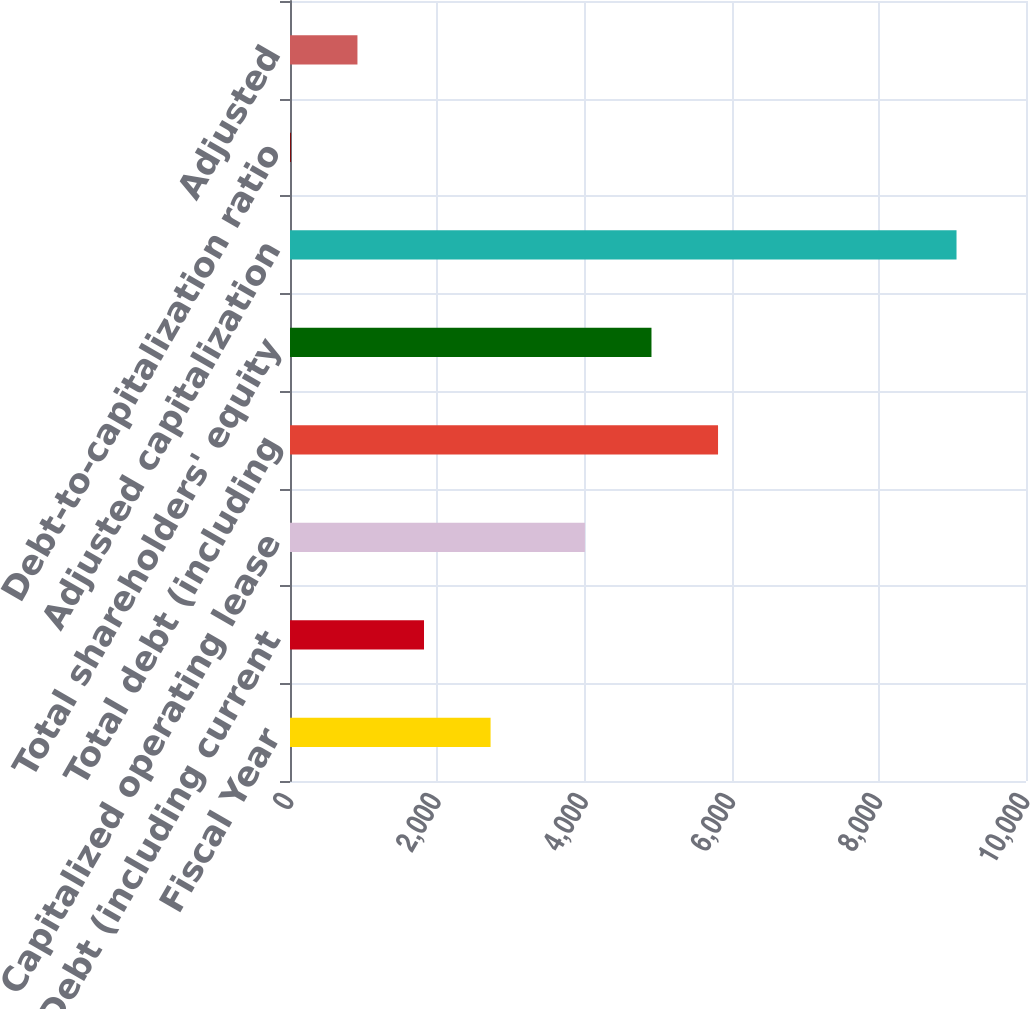<chart> <loc_0><loc_0><loc_500><loc_500><bar_chart><fcel>Fiscal Year<fcel>Debt (including current<fcel>Capitalized operating lease<fcel>Total debt (including<fcel>Total shareholders' equity<fcel>Adjusted capitalization<fcel>Debt-to-capitalization ratio<fcel>Adjusted<nl><fcel>2725.2<fcel>1820.8<fcel>4007<fcel>5815.8<fcel>4911.4<fcel>9056<fcel>12<fcel>916.4<nl></chart> 